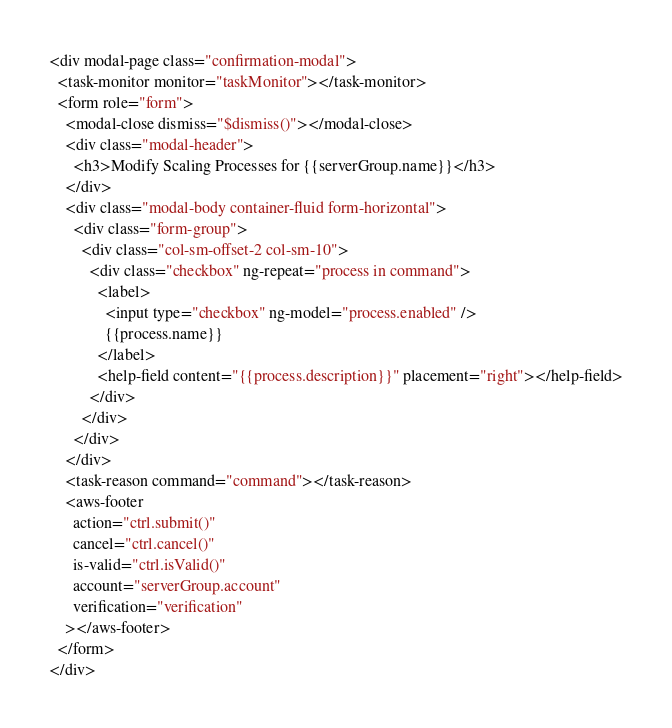Convert code to text. <code><loc_0><loc_0><loc_500><loc_500><_HTML_><div modal-page class="confirmation-modal">
  <task-monitor monitor="taskMonitor"></task-monitor>
  <form role="form">
    <modal-close dismiss="$dismiss()"></modal-close>
    <div class="modal-header">
      <h3>Modify Scaling Processes for {{serverGroup.name}}</h3>
    </div>
    <div class="modal-body container-fluid form-horizontal">
      <div class="form-group">
        <div class="col-sm-offset-2 col-sm-10">
          <div class="checkbox" ng-repeat="process in command">
            <label>
              <input type="checkbox" ng-model="process.enabled" />
              {{process.name}}
            </label>
            <help-field content="{{process.description}}" placement="right"></help-field>
          </div>
        </div>
      </div>
    </div>
    <task-reason command="command"></task-reason>
    <aws-footer
      action="ctrl.submit()"
      cancel="ctrl.cancel()"
      is-valid="ctrl.isValid()"
      account="serverGroup.account"
      verification="verification"
    ></aws-footer>
  </form>
</div>
</code> 